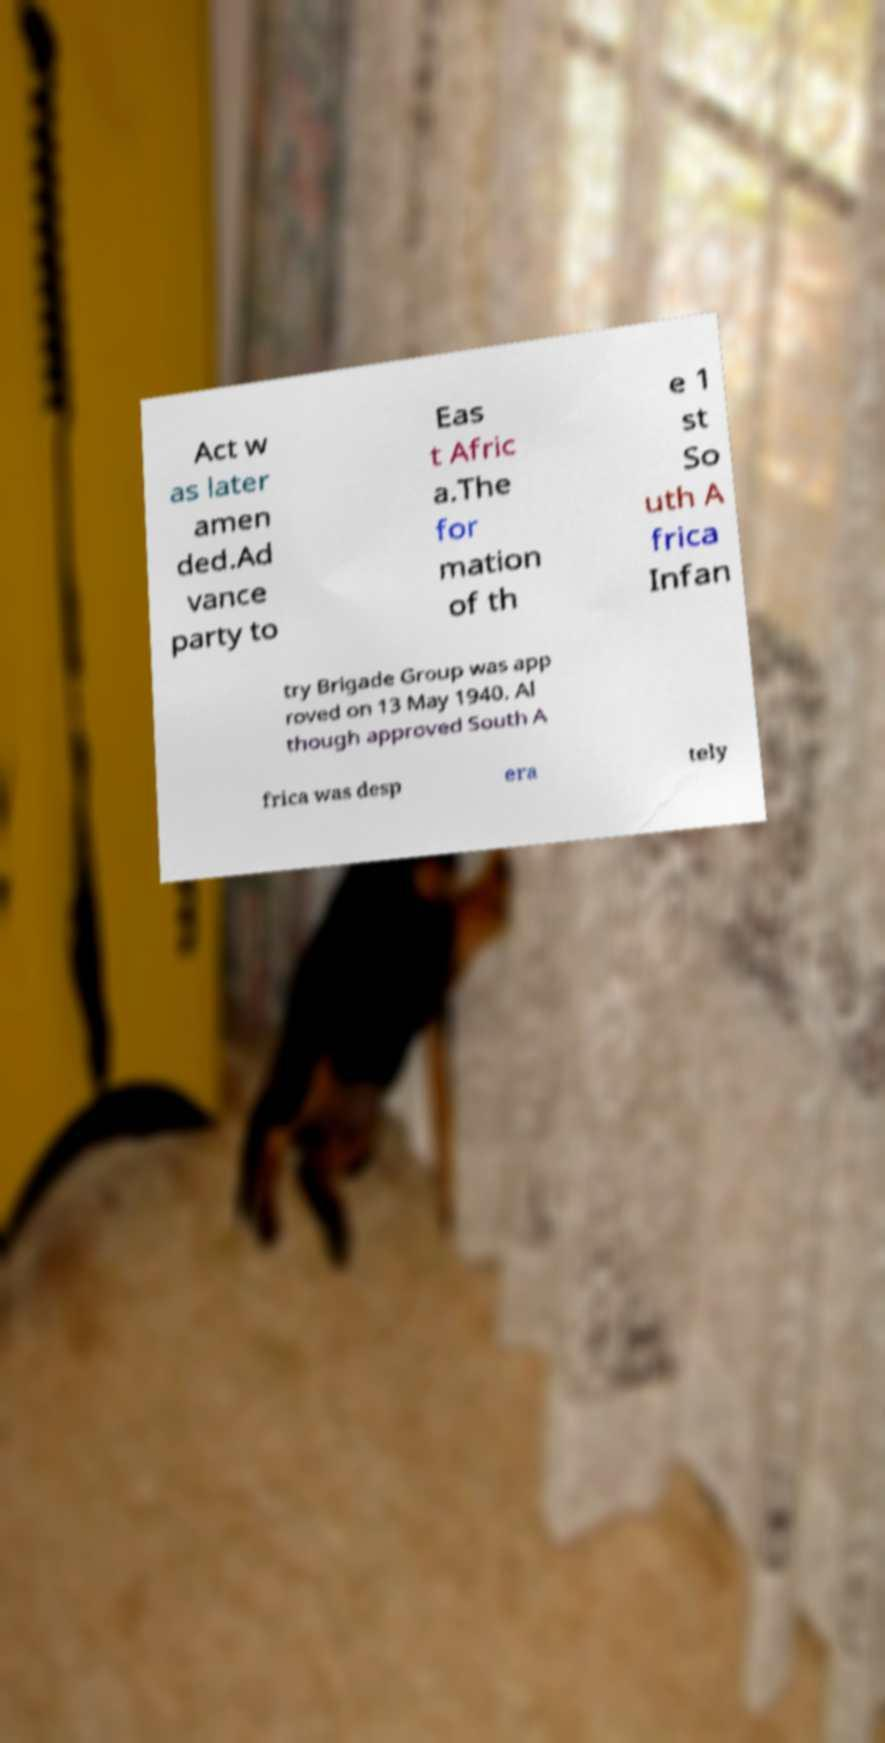Could you extract and type out the text from this image? Act w as later amen ded.Ad vance party to Eas t Afric a.The for mation of th e 1 st So uth A frica Infan try Brigade Group was app roved on 13 May 1940. Al though approved South A frica was desp era tely 